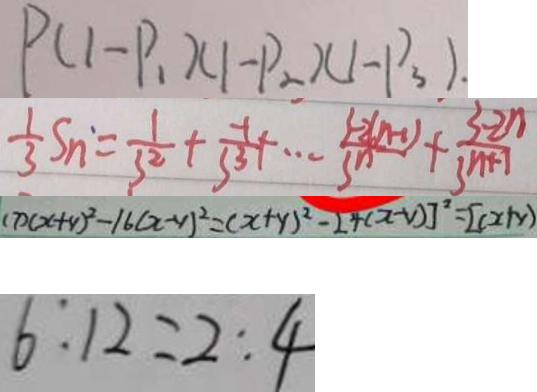Convert formula to latex. <formula><loc_0><loc_0><loc_500><loc_500>P ( 1 - P _ { 1 } ) ( 1 - P _ { 2 } ) ( 1 - P _ { 3 } ) . 
 \frac { 1 } { 3 } S _ { n } = \frac { 1 } { 3 ^ { 2 } } + \frac { - 1 } { 3 ^ { 3 } } + \cdots \frac { 3 - 2 ( n - 1 ) } { 3 ^ { n } } + \frac { 3 - 2 n } { 3 n + 1 } 
 ( 7 ) ( x + y ) ^ { 2 } - 1 6 ( x - y ) ^ { 2 } = ( x + y ) ^ { 2 } - 2 4 ( x - y ) ] ^ { 2 } = [ ( x + y ) 
 6 : 1 2 = 2 : 4</formula> 